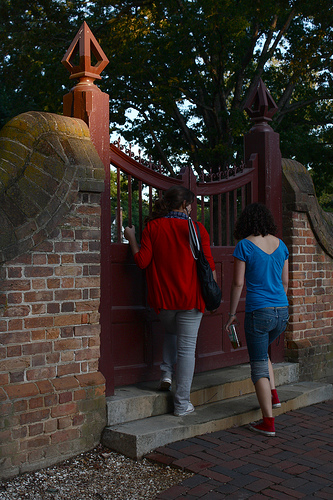<image>
Can you confirm if the pant leg is under the purse? Yes. The pant leg is positioned underneath the purse, with the purse above it in the vertical space. Is the female to the right of the female? No. The female is not to the right of the female. The horizontal positioning shows a different relationship. 